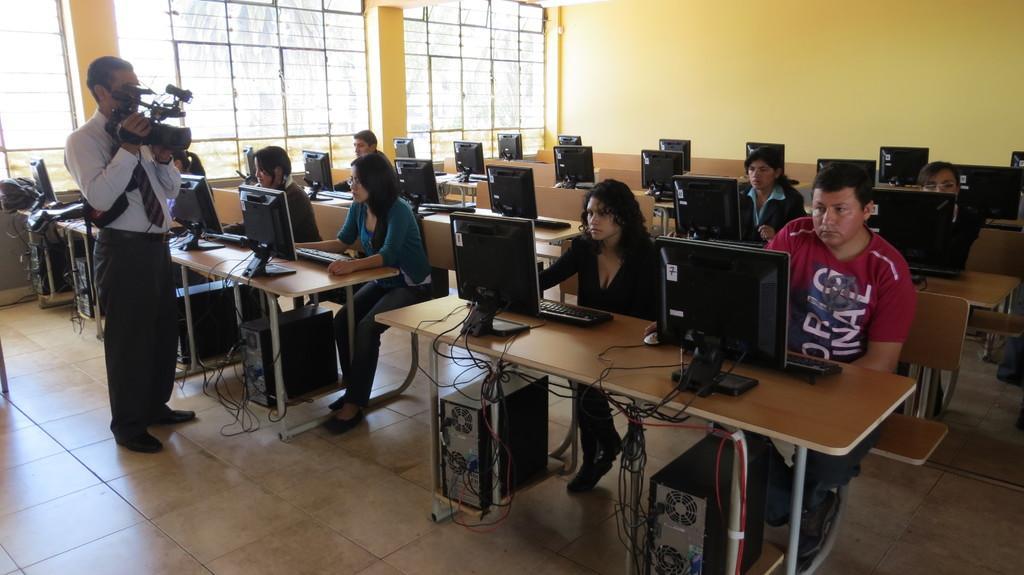Please provide a concise description of this image. Here this is the inside view of a room. and here there are so many systems present in this room. And if we observe there are four members sitting on the bench and looking in to the system. And also on the right side there are four people sitting on the bench and observing into the system. And one more person is standing here and holding the camera. Coming to the background there is a yellow colored wall. On the left there is a window. And this is the floor. 